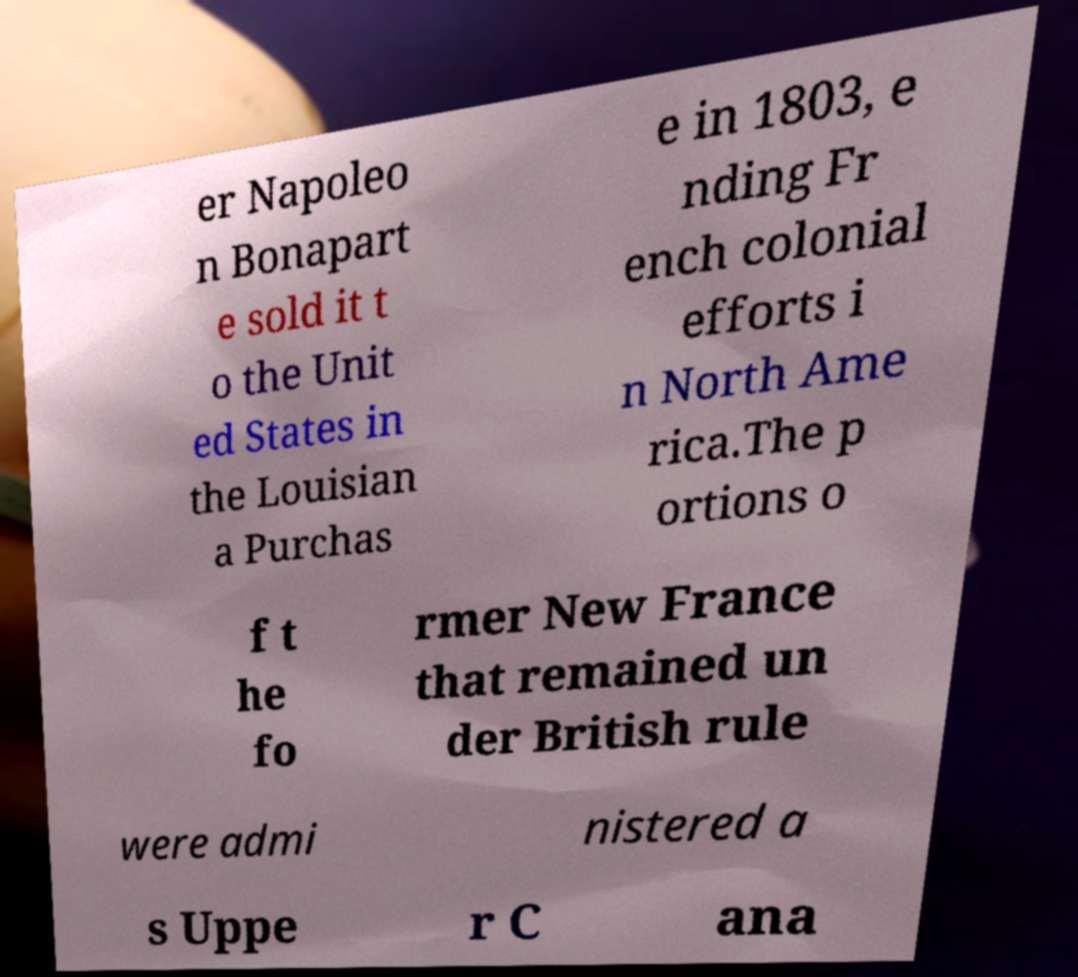For documentation purposes, I need the text within this image transcribed. Could you provide that? er Napoleo n Bonapart e sold it t o the Unit ed States in the Louisian a Purchas e in 1803, e nding Fr ench colonial efforts i n North Ame rica.The p ortions o f t he fo rmer New France that remained un der British rule were admi nistered a s Uppe r C ana 